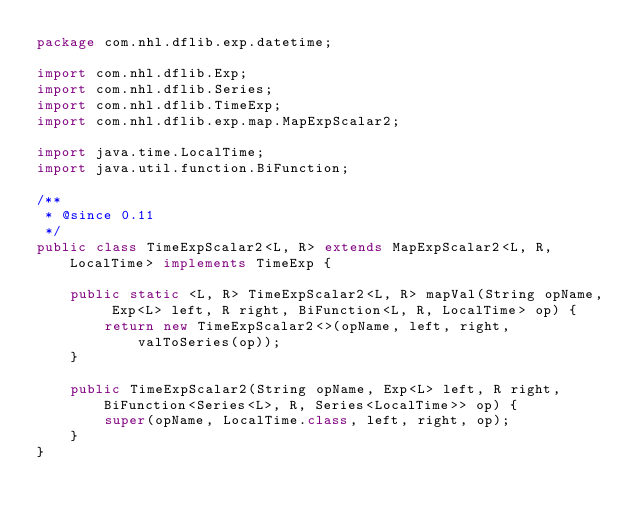<code> <loc_0><loc_0><loc_500><loc_500><_Java_>package com.nhl.dflib.exp.datetime;

import com.nhl.dflib.Exp;
import com.nhl.dflib.Series;
import com.nhl.dflib.TimeExp;
import com.nhl.dflib.exp.map.MapExpScalar2;

import java.time.LocalTime;
import java.util.function.BiFunction;

/**
 * @since 0.11
 */
public class TimeExpScalar2<L, R> extends MapExpScalar2<L, R, LocalTime> implements TimeExp {

    public static <L, R> TimeExpScalar2<L, R> mapVal(String opName, Exp<L> left, R right, BiFunction<L, R, LocalTime> op) {
        return new TimeExpScalar2<>(opName, left, right, valToSeries(op));
    }

    public TimeExpScalar2(String opName, Exp<L> left, R right, BiFunction<Series<L>, R, Series<LocalTime>> op) {
        super(opName, LocalTime.class, left, right, op);
    }
}
</code> 